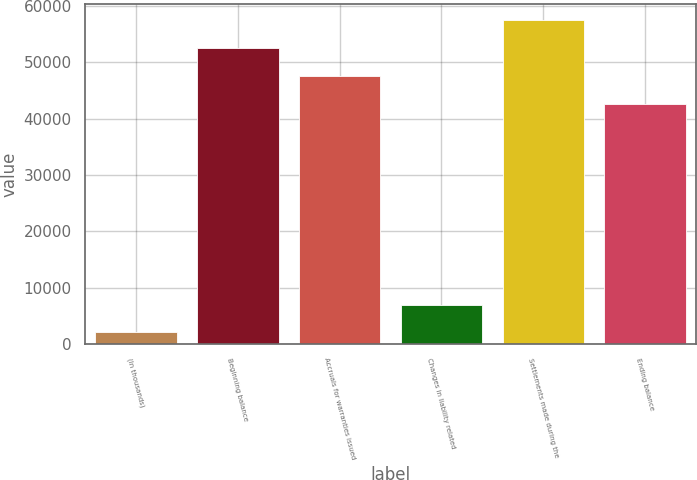Convert chart. <chart><loc_0><loc_0><loc_500><loc_500><bar_chart><fcel>(In thousands)<fcel>Beginning balance<fcel>Accruals for warranties issued<fcel>Changes in liability related<fcel>Settlements made during the<fcel>Ending balance<nl><fcel>2013<fcel>52538.6<fcel>47570.8<fcel>6980.8<fcel>57506.4<fcel>42603<nl></chart> 